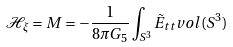<formula> <loc_0><loc_0><loc_500><loc_500>\mathcal { H } _ { \xi } = M = - \frac { 1 } { 8 \pi G _ { 5 } } \int _ { S ^ { 3 } } \tilde { E } _ { t t } v o l ( S ^ { 3 } )</formula> 